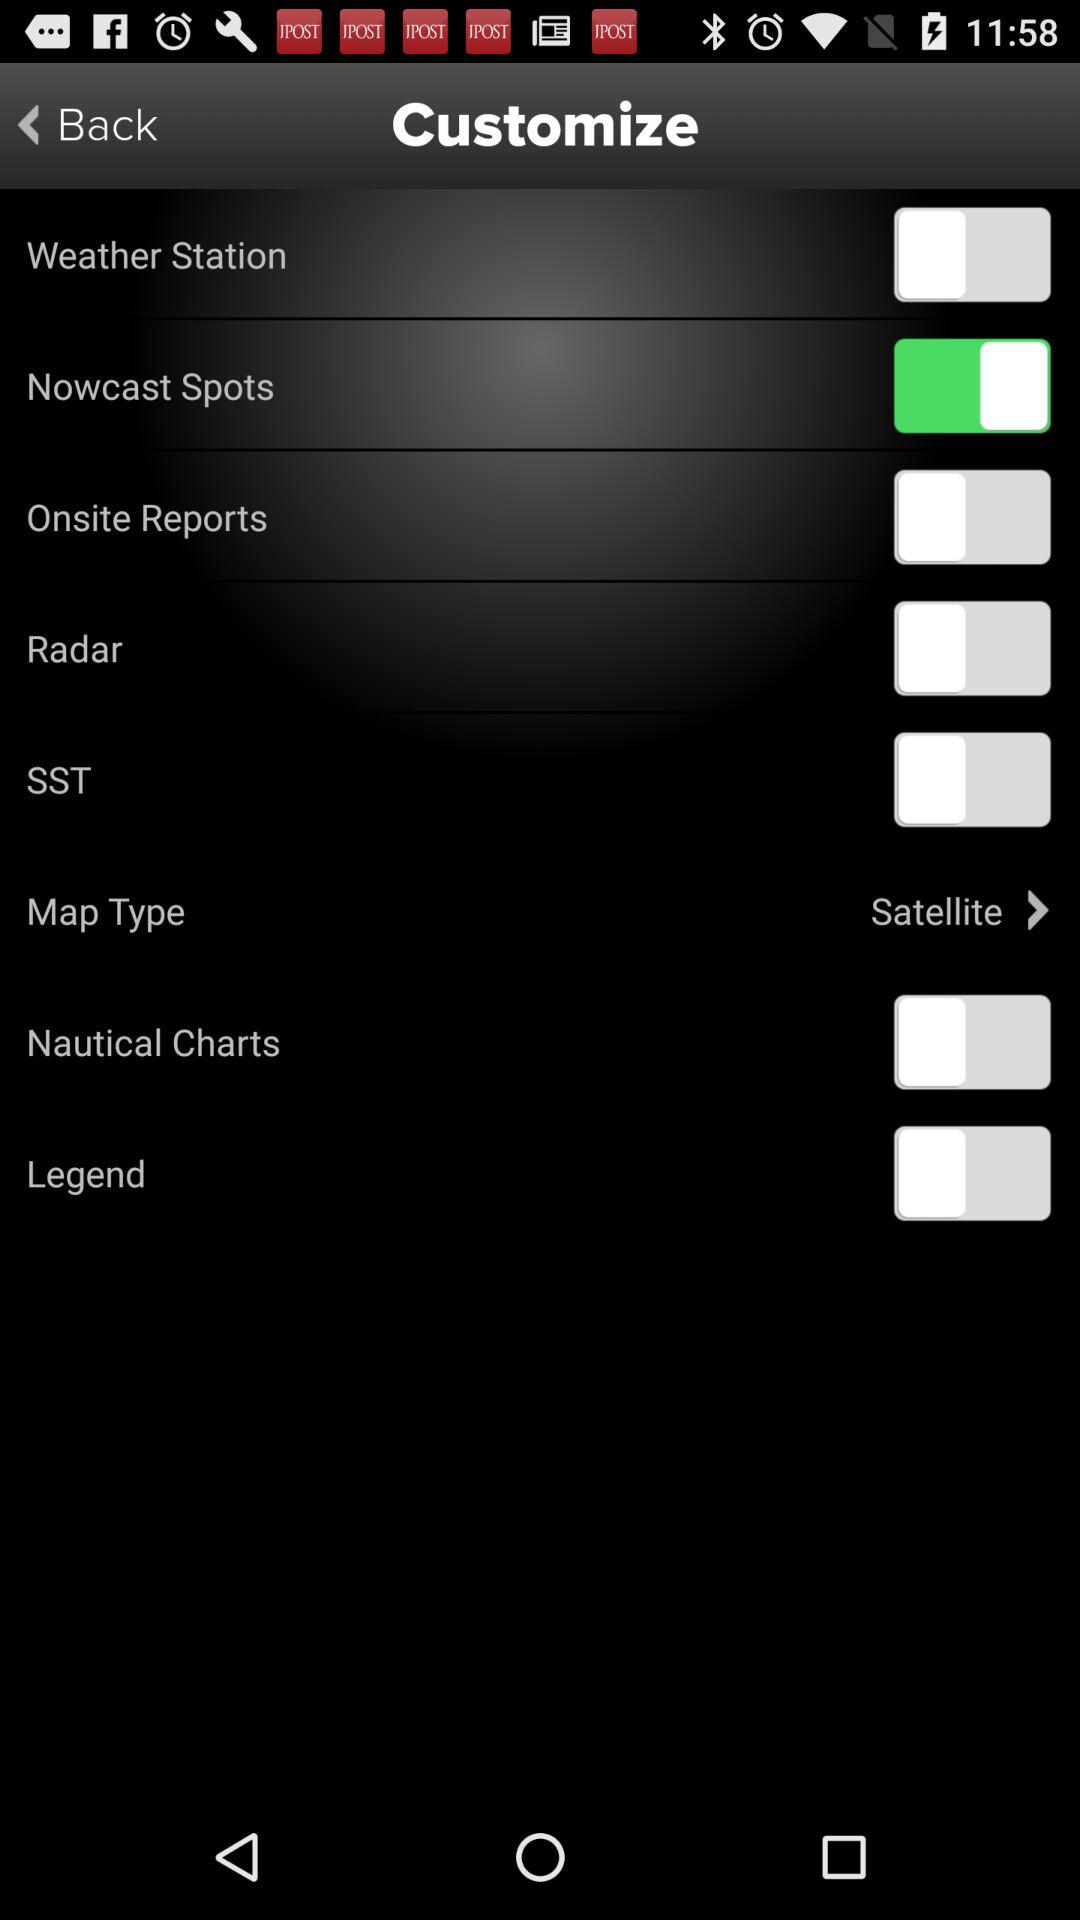What is the selected map type? The selected map type is "Satellite". 